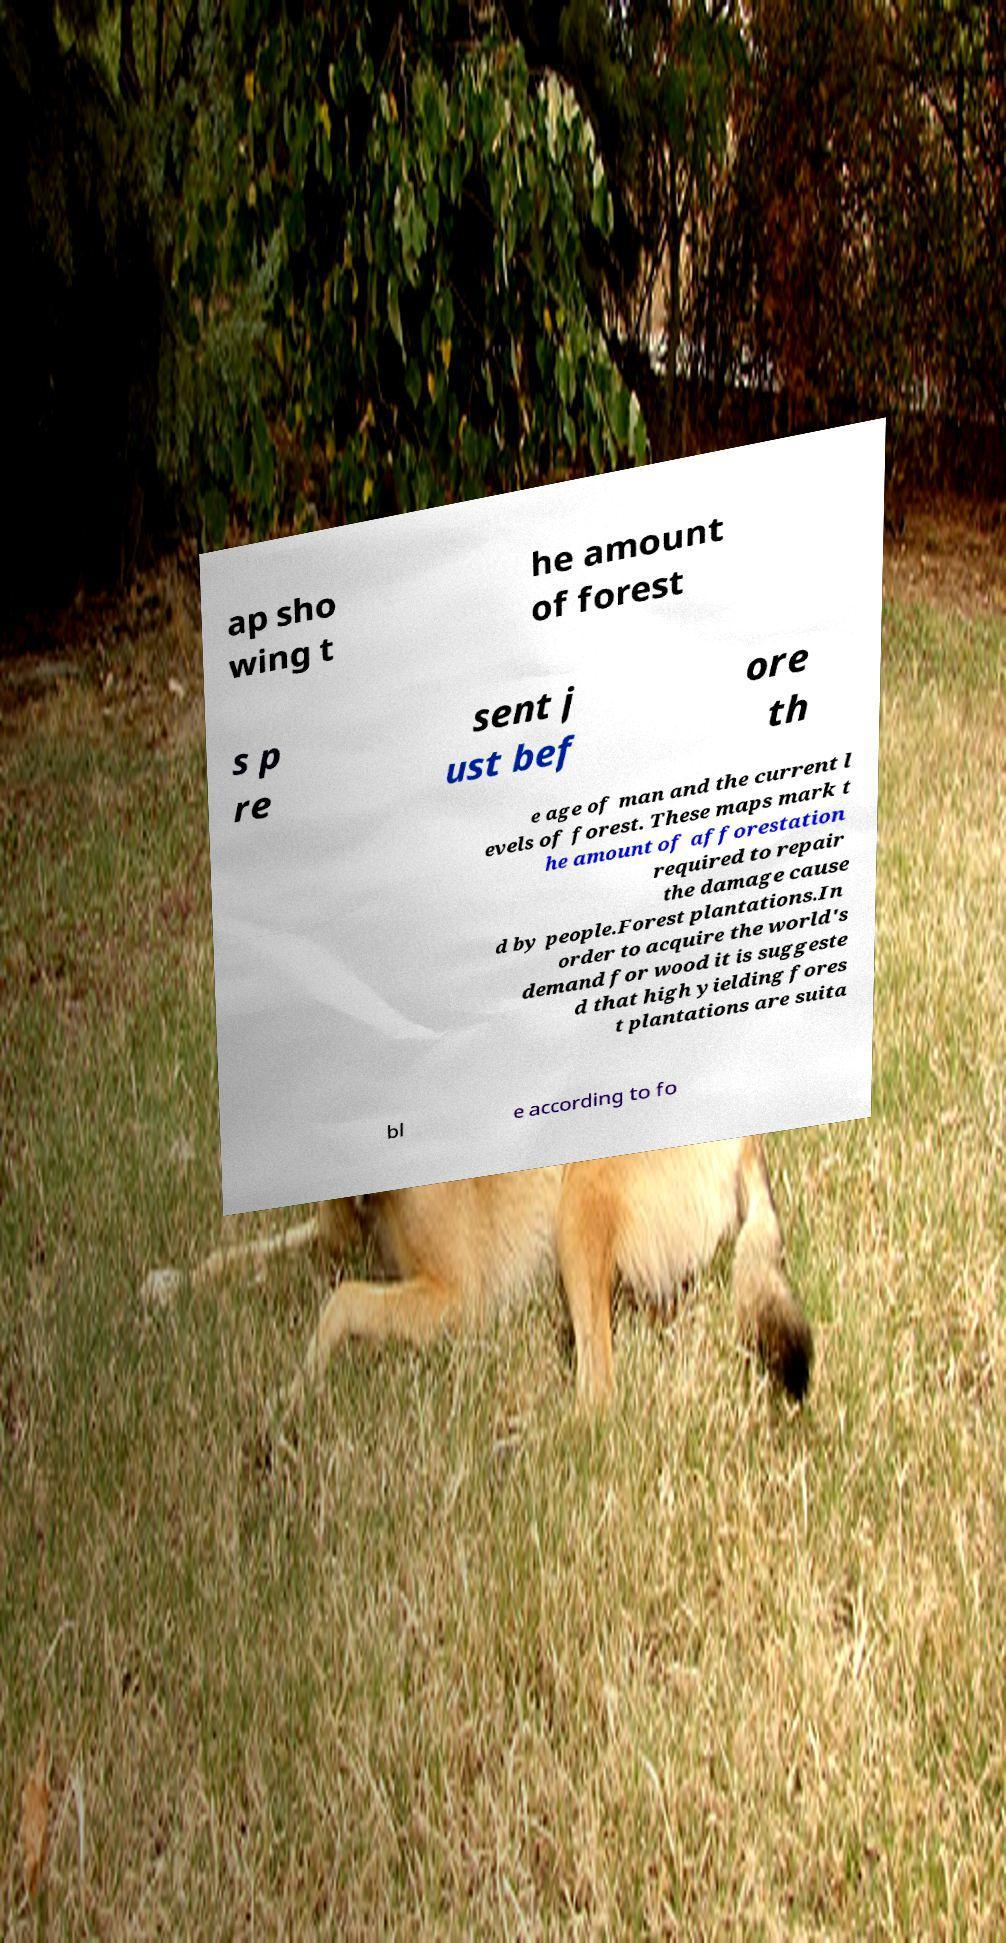Can you read and provide the text displayed in the image?This photo seems to have some interesting text. Can you extract and type it out for me? ap sho wing t he amount of forest s p re sent j ust bef ore th e age of man and the current l evels of forest. These maps mark t he amount of afforestation required to repair the damage cause d by people.Forest plantations.In order to acquire the world's demand for wood it is suggeste d that high yielding fores t plantations are suita bl e according to fo 